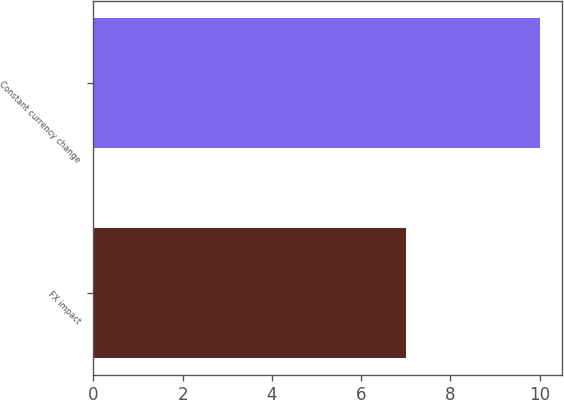Convert chart to OTSL. <chart><loc_0><loc_0><loc_500><loc_500><bar_chart><fcel>FX impact<fcel>Constant currency change<nl><fcel>7<fcel>10<nl></chart> 